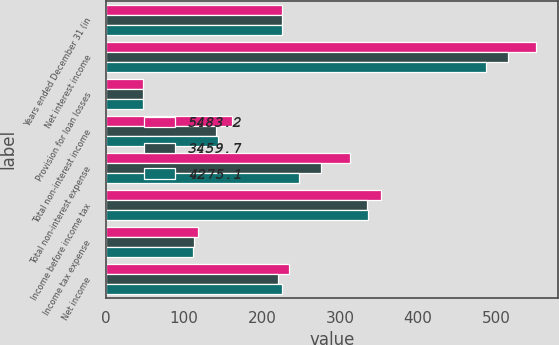<chart> <loc_0><loc_0><loc_500><loc_500><stacked_bar_chart><ecel><fcel>Years ended December 31 (in<fcel>Net interest income<fcel>Provision for loan losses<fcel>Total non-interest income<fcel>Total non-interest expense<fcel>Income before income tax<fcel>Income tax expense<fcel>Net income<nl><fcel>5483.2<fcel>224.9<fcel>551.6<fcel>47.7<fcel>162<fcel>313.2<fcel>352.7<fcel>117.9<fcel>234.8<nl><fcel>3459.7<fcel>224.9<fcel>516<fcel>47.6<fcel>141.4<fcel>275.7<fcel>334.1<fcel>113.1<fcel>221<nl><fcel>4275.1<fcel>224.9<fcel>487.7<fcel>47.3<fcel>143.3<fcel>247.4<fcel>336.3<fcel>111.4<fcel>224.9<nl></chart> 